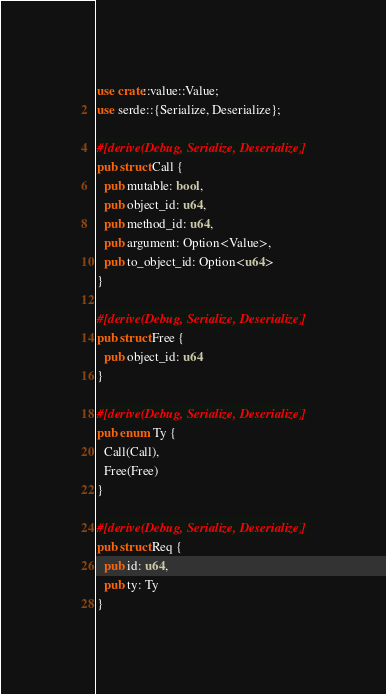<code> <loc_0><loc_0><loc_500><loc_500><_Rust_>use crate::value::Value;
use serde::{Serialize, Deserialize};

#[derive(Debug, Serialize, Deserialize)]
pub struct Call {
  pub mutable: bool,
  pub object_id: u64,
  pub method_id: u64,
  pub argument: Option<Value>,
  pub to_object_id: Option<u64>
}

#[derive(Debug, Serialize, Deserialize)]
pub struct Free {
  pub object_id: u64
}

#[derive(Debug, Serialize, Deserialize)]
pub enum Ty {
  Call(Call),
  Free(Free)
}

#[derive(Debug, Serialize, Deserialize)]
pub struct Req {
  pub id: u64,
  pub ty: Ty
}</code> 